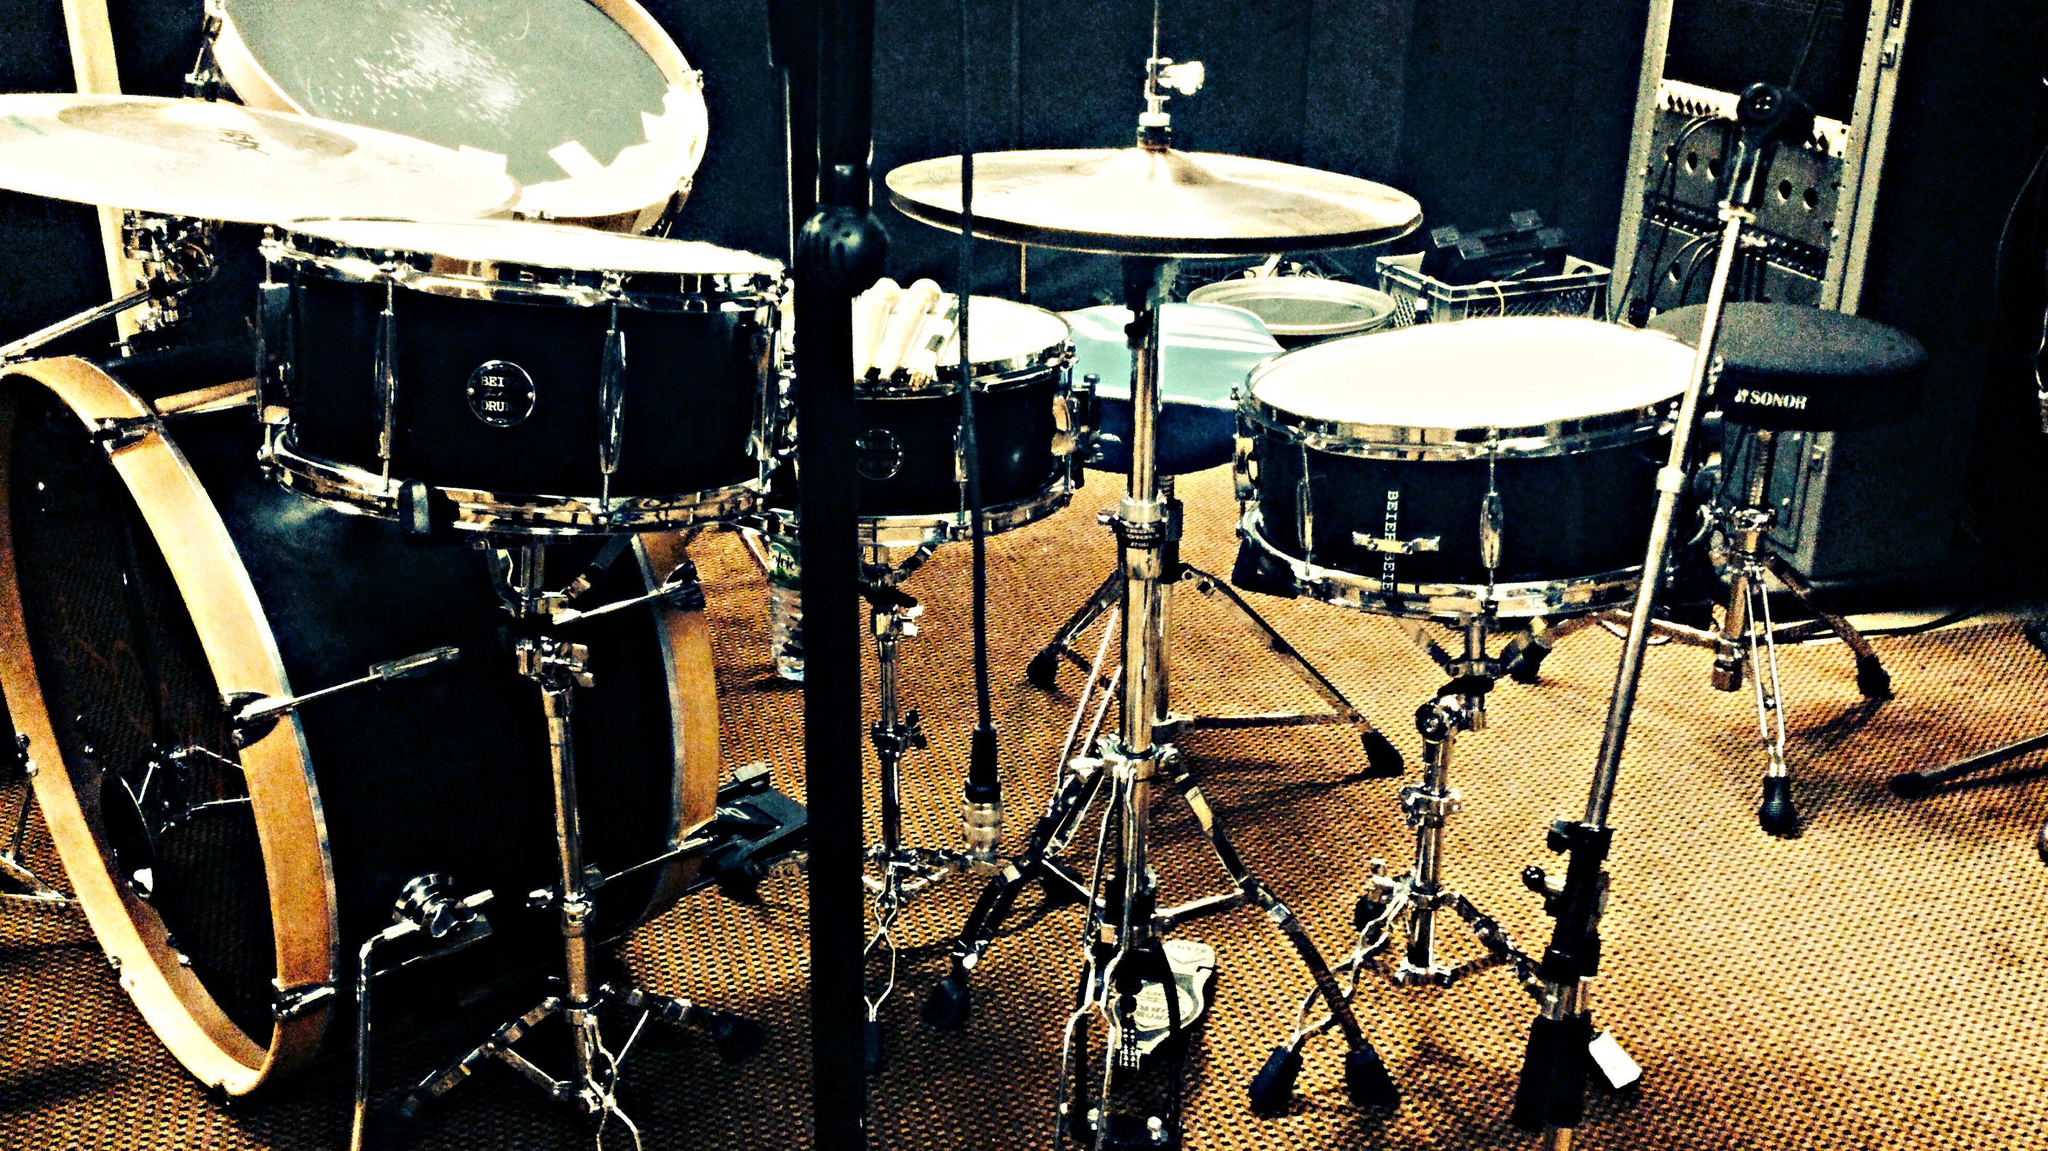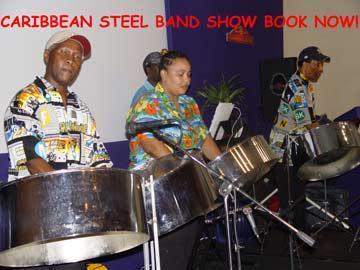The first image is the image on the left, the second image is the image on the right. Analyze the images presented: Is the assertion "One drummer is wearing a floral print shirt." valid? Answer yes or no. Yes. The first image is the image on the left, the second image is the image on the right. Considering the images on both sides, is "There are three men standing next to each-other in the image on the left." valid? Answer yes or no. No. 